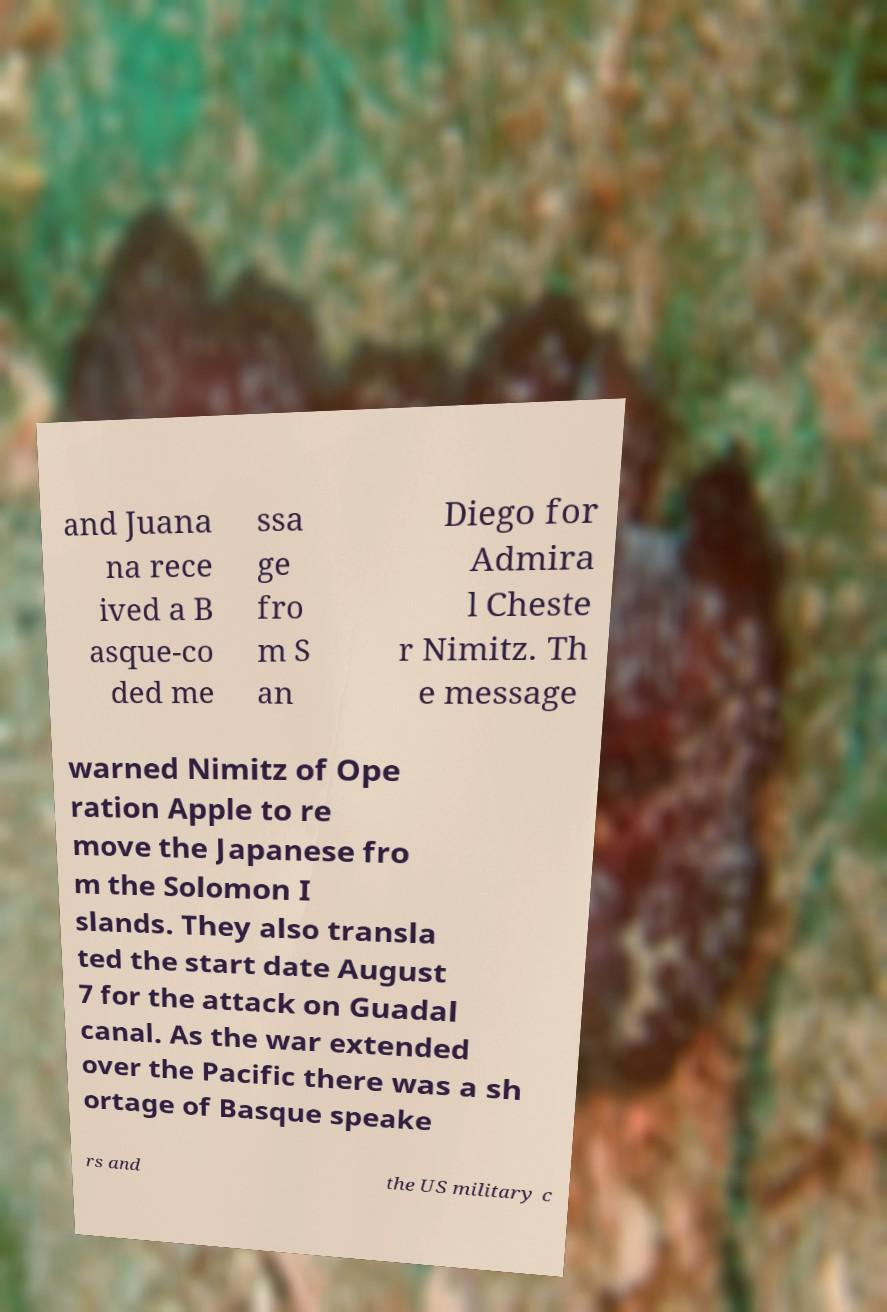For documentation purposes, I need the text within this image transcribed. Could you provide that? and Juana na rece ived a B asque-co ded me ssa ge fro m S an Diego for Admira l Cheste r Nimitz. Th e message warned Nimitz of Ope ration Apple to re move the Japanese fro m the Solomon I slands. They also transla ted the start date August 7 for the attack on Guadal canal. As the war extended over the Pacific there was a sh ortage of Basque speake rs and the US military c 